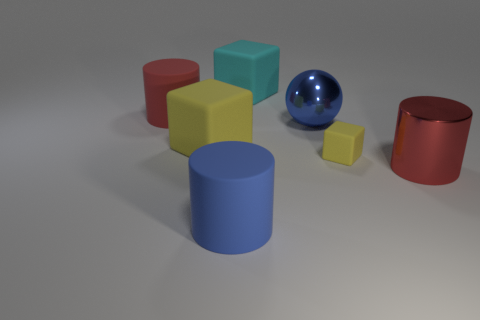Add 2 large cyan matte cubes. How many objects exist? 9 Subtract all blocks. How many objects are left? 4 Subtract 0 purple blocks. How many objects are left? 7 Subtract all large yellow objects. Subtract all spheres. How many objects are left? 5 Add 1 big yellow objects. How many big yellow objects are left? 2 Add 3 big blue metallic objects. How many big blue metallic objects exist? 4 